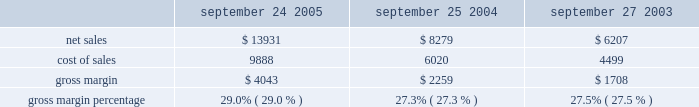Expansion of the retail segment has required and will continue to require a substantial investment in fixed assets and related infrastructure , operating lease commitments , personnel , and other operating expenses .
Capital expenditures associated with the retail segment were $ 132 million in 2005 , bringing the total capital expenditures since inception of the retail segment to approximately $ 529 million .
As of september 24 , 2005 , the retail segment had approximately 3673 employees and had outstanding operating lease commitments associated with retail store space and related facilities of approximately $ 606 million .
The company would incur substantial costs should it choose to terminate its retail segment or close individual stores .
Such costs could adversely affect the company 2019s results of operations and financial condition .
Gross margin gross margin for each of the last three fiscal years are as follows ( in millions , except gross margin percentages ) : september 24 , september 25 , september 27 .
Gross margin increased in 2005 to 29.0% ( 29.0 % ) of net sales from 27.3% ( 27.3 % ) of net sales in 2004 .
The company 2019s gross margin during 2005 increased due to more favorable pricing on certain commodity components including lcd flat-panel displays and dram memory ; an increase in higher margin software sales ; a favorable shift in direct sales related primarily to the company 2019s retail and online stores ; and higher overall revenue that provided for more leverage on fixed production costs .
These increases to gross margin were partially offset by an increase in lower margin ipod sales .
The company anticipates that its gross margin and the gross margin of the overall personal computer and consumer electronics industries will remain under pressure in light of price competition , especially for the ipod product line .
The company expects gross margin percentage to decline in the first quarter of 2006 primarily as a result of a shift in the mix of revenue toward lower margin products such as the ipod and content from the itunes music store .
The foregoing statements regarding the company 2019s expected gross margin are forward-looking .
There can be no assurance that current gross margins will be maintained or targeted gross margin levels will be achieved .
In general , gross margins and margins on individual products , including ipods , will remain under significant downward pressure due to a variety of factors , including continued industry wide global pricing pressures , increased competition , compressed product life cycles , potential increases in the cost and availability of raw material and outside manufacturing services , and potential changes to the company 2019s product mix , including higher unit sales of consumer products with lower average selling prices and lower gross margins .
In response to these downward pressures , the company expects it will continue to take pricing actions with respect to its products .
Gross margins could also be affected by the company 2019s ability to effectively manage product quality and warranty costs and to stimulate demand for certain of its products .
Due to the company 2019s significant international operations , financial results can be significantly affected in the short-term by fluctuations in exchange rates. .
What was the largest gross margin in millions dollars over the three year period? 
Computations: table_max(gross margin, none)
Answer: 4043.0. 